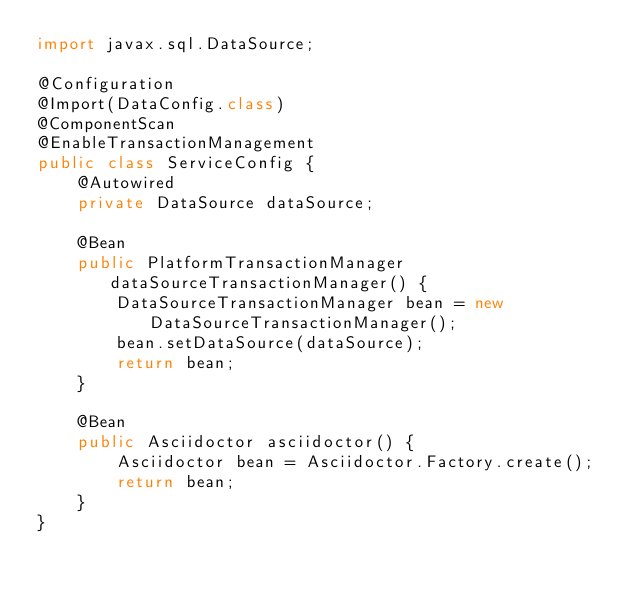Convert code to text. <code><loc_0><loc_0><loc_500><loc_500><_Java_>import javax.sql.DataSource;

@Configuration
@Import(DataConfig.class)
@ComponentScan
@EnableTransactionManagement
public class ServiceConfig {
    @Autowired
    private DataSource dataSource;

    @Bean
    public PlatformTransactionManager dataSourceTransactionManager() {
        DataSourceTransactionManager bean = new DataSourceTransactionManager();
        bean.setDataSource(dataSource);
        return bean;
    }

    @Bean
    public Asciidoctor asciidoctor() {
        Asciidoctor bean = Asciidoctor.Factory.create();
        return bean;
    }
}
</code> 